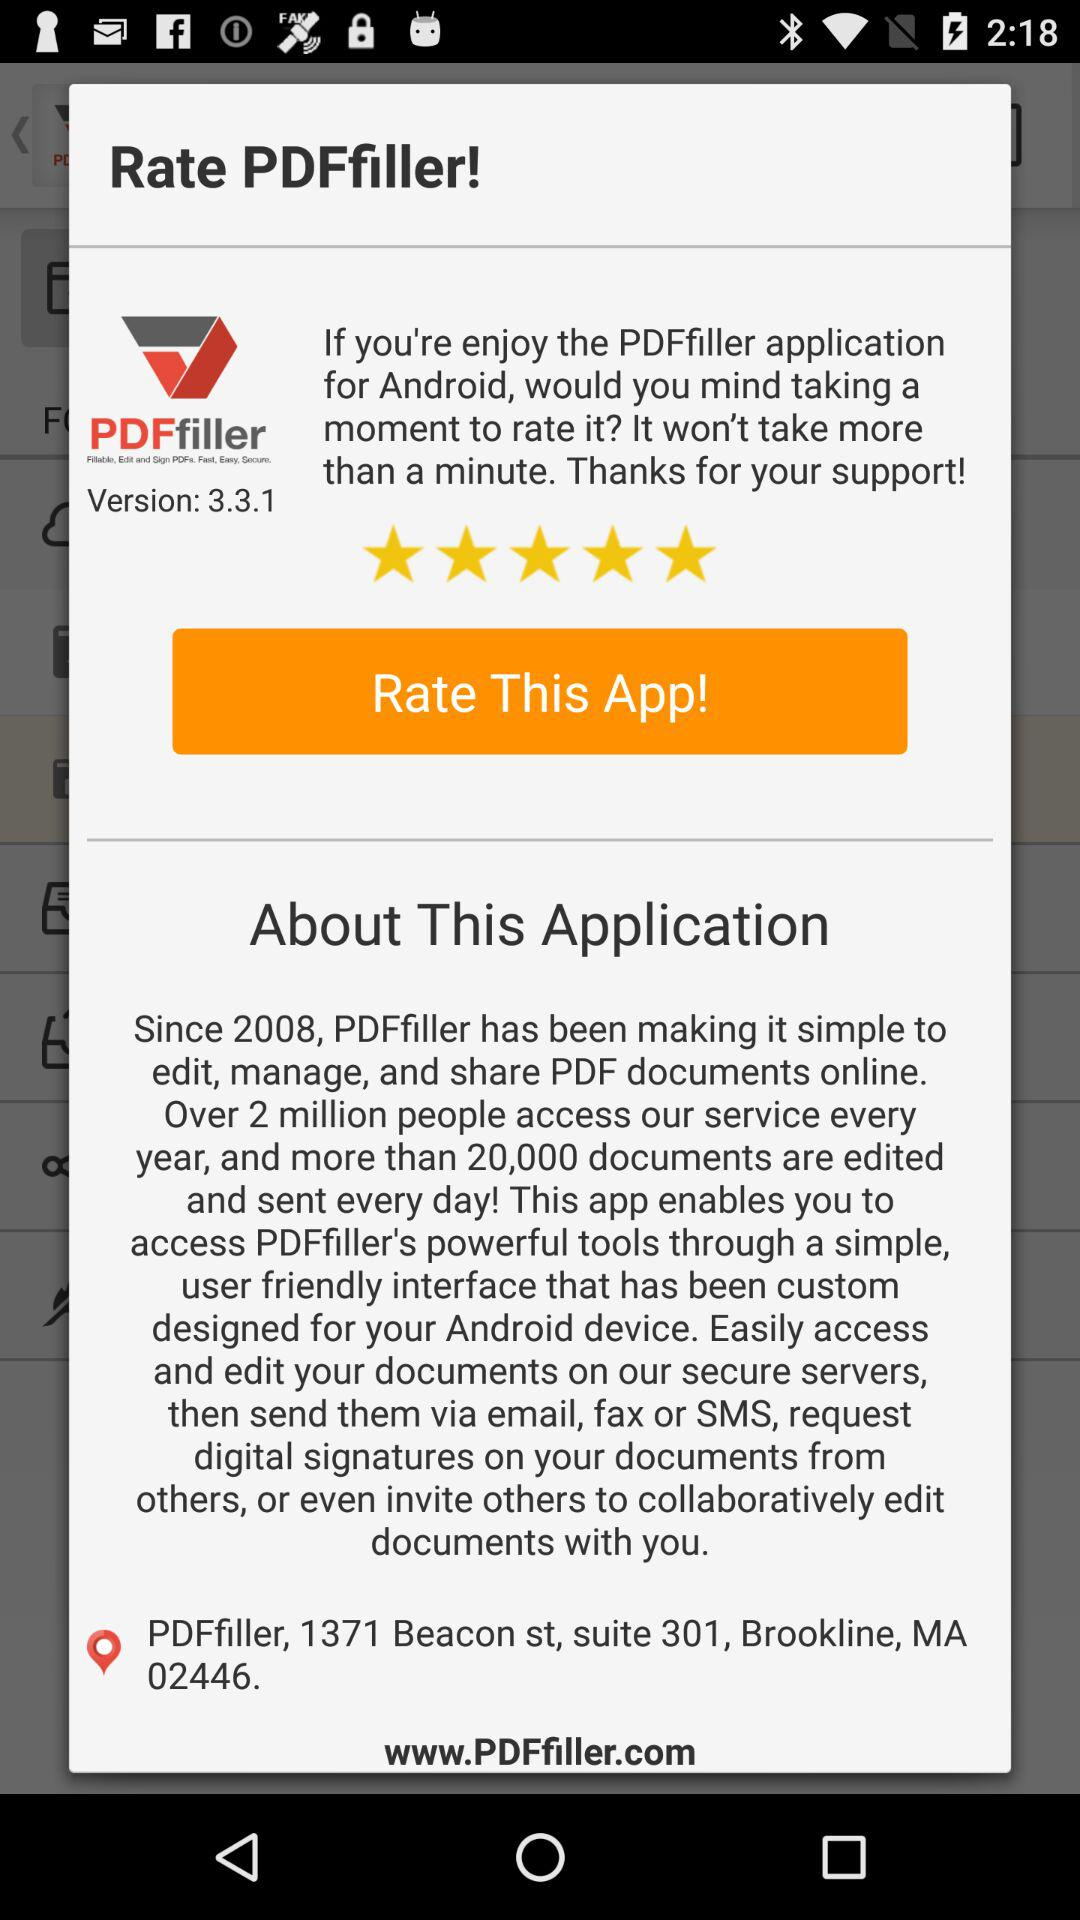What is the rating of "PDFfiller"? The rating is 5 stars. 